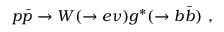<formula> <loc_0><loc_0><loc_500><loc_500>p \bar { p } \rightarrow W ( \rightarrow e \nu ) g ^ { * } ( \rightarrow b \bar { b } ) \ ,</formula> 